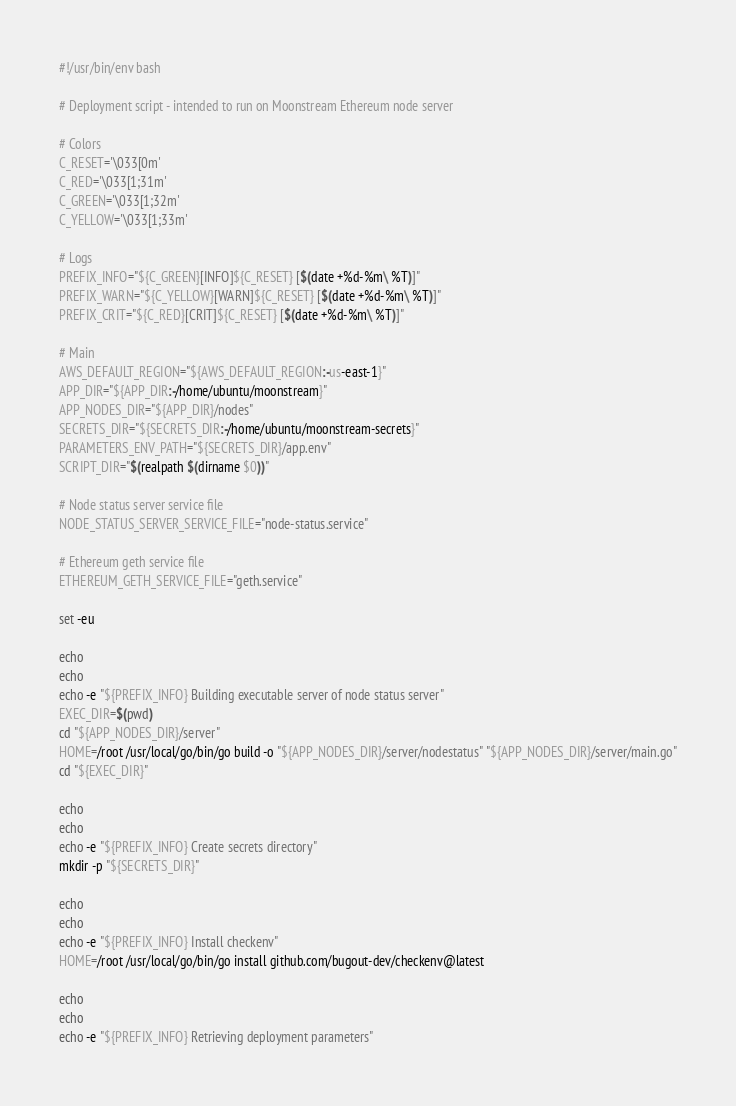Convert code to text. <code><loc_0><loc_0><loc_500><loc_500><_Bash_>#!/usr/bin/env bash

# Deployment script - intended to run on Moonstream Ethereum node server

# Colors
C_RESET='\033[0m'
C_RED='\033[1;31m'
C_GREEN='\033[1;32m'
C_YELLOW='\033[1;33m'

# Logs
PREFIX_INFO="${C_GREEN}[INFO]${C_RESET} [$(date +%d-%m\ %T)]"
PREFIX_WARN="${C_YELLOW}[WARN]${C_RESET} [$(date +%d-%m\ %T)]"
PREFIX_CRIT="${C_RED}[CRIT]${C_RESET} [$(date +%d-%m\ %T)]"

# Main
AWS_DEFAULT_REGION="${AWS_DEFAULT_REGION:-us-east-1}"
APP_DIR="${APP_DIR:-/home/ubuntu/moonstream}"
APP_NODES_DIR="${APP_DIR}/nodes"
SECRETS_DIR="${SECRETS_DIR:-/home/ubuntu/moonstream-secrets}"
PARAMETERS_ENV_PATH="${SECRETS_DIR}/app.env"
SCRIPT_DIR="$(realpath $(dirname $0))"

# Node status server service file
NODE_STATUS_SERVER_SERVICE_FILE="node-status.service"

# Ethereum geth service file
ETHEREUM_GETH_SERVICE_FILE="geth.service"

set -eu

echo
echo
echo -e "${PREFIX_INFO} Building executable server of node status server"
EXEC_DIR=$(pwd)
cd "${APP_NODES_DIR}/server"
HOME=/root /usr/local/go/bin/go build -o "${APP_NODES_DIR}/server/nodestatus" "${APP_NODES_DIR}/server/main.go"
cd "${EXEC_DIR}"

echo
echo
echo -e "${PREFIX_INFO} Create secrets directory"
mkdir -p "${SECRETS_DIR}"

echo
echo
echo -e "${PREFIX_INFO} Install checkenv"
HOME=/root /usr/local/go/bin/go install github.com/bugout-dev/checkenv@latest

echo
echo
echo -e "${PREFIX_INFO} Retrieving deployment parameters"</code> 